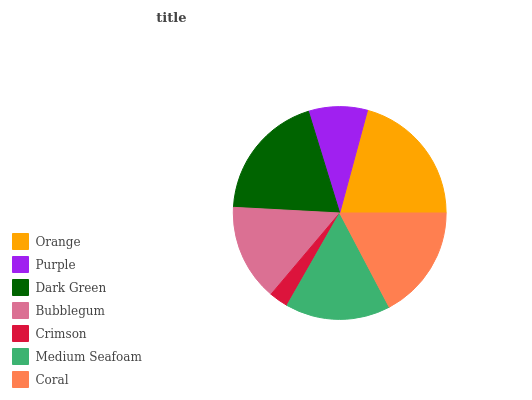Is Crimson the minimum?
Answer yes or no. Yes. Is Orange the maximum?
Answer yes or no. Yes. Is Purple the minimum?
Answer yes or no. No. Is Purple the maximum?
Answer yes or no. No. Is Orange greater than Purple?
Answer yes or no. Yes. Is Purple less than Orange?
Answer yes or no. Yes. Is Purple greater than Orange?
Answer yes or no. No. Is Orange less than Purple?
Answer yes or no. No. Is Medium Seafoam the high median?
Answer yes or no. Yes. Is Medium Seafoam the low median?
Answer yes or no. Yes. Is Dark Green the high median?
Answer yes or no. No. Is Crimson the low median?
Answer yes or no. No. 